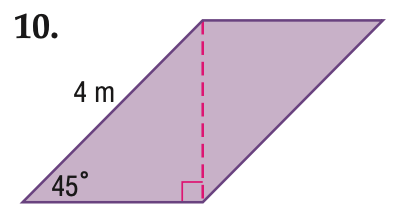Question: Find the area of the parallelogram. Round to the nearest tenth if necessary.
Choices:
A. 4
B. 8
C. 12
D. 16
Answer with the letter. Answer: B Question: Find the perimeter of the parallelogram. Round to the nearest tenth if necessary.
Choices:
A. 10
B. 13.7
C. 14.9
D. 16
Answer with the letter. Answer: B 